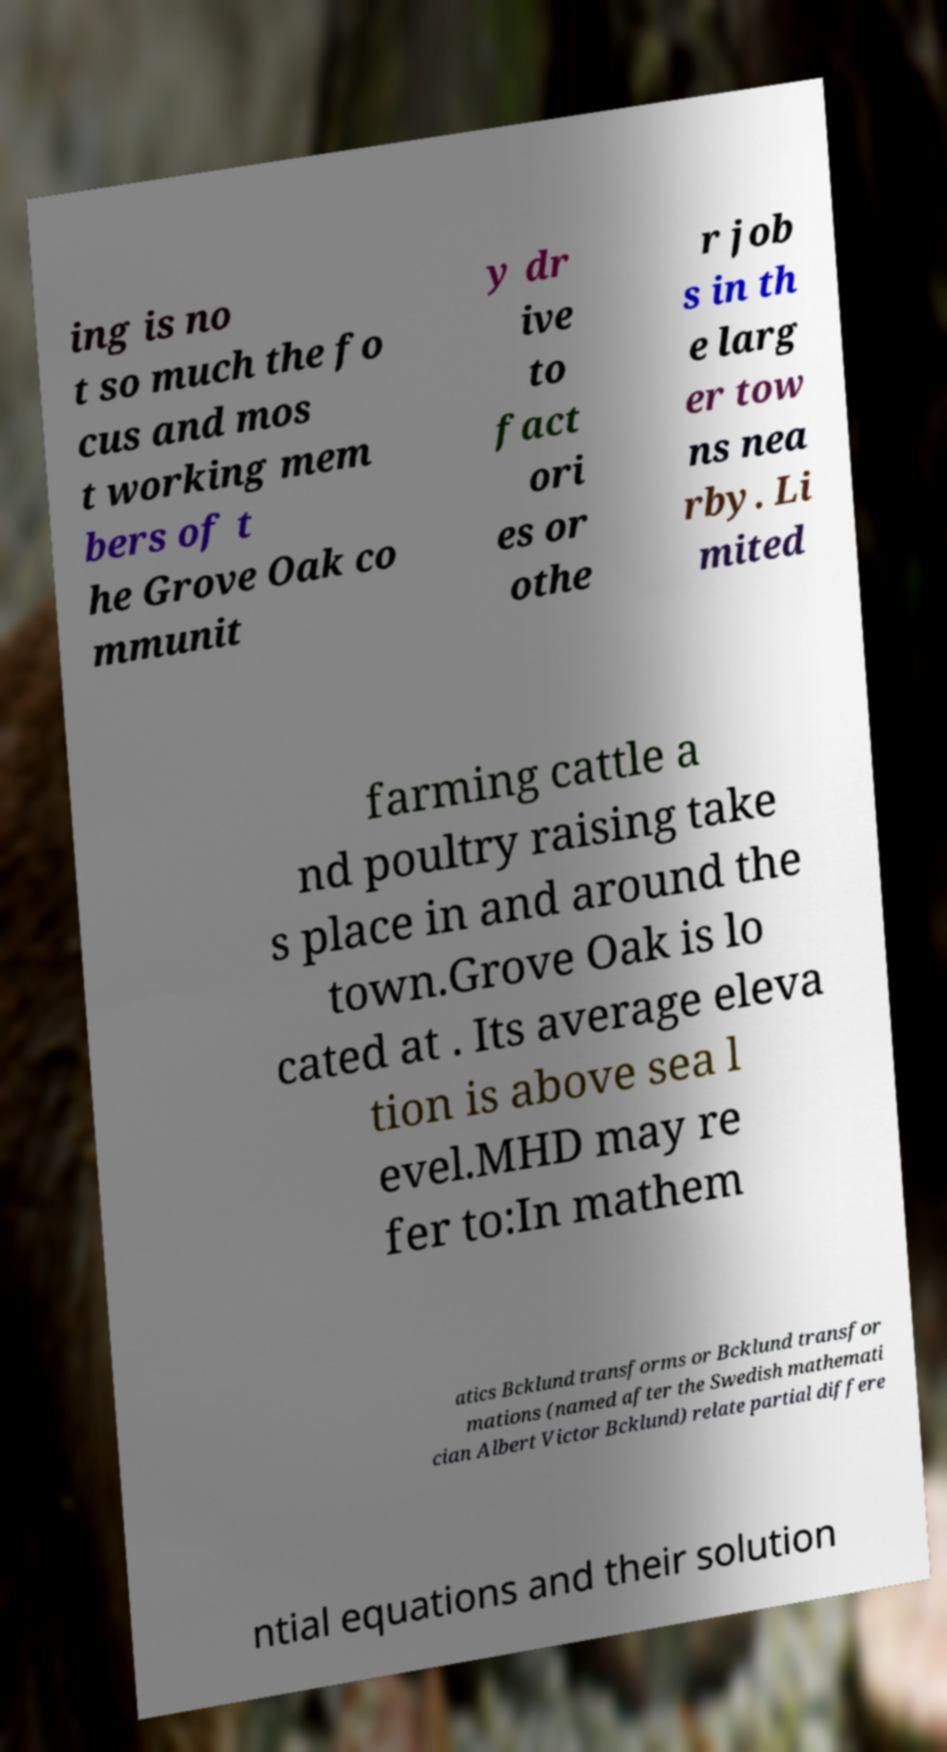There's text embedded in this image that I need extracted. Can you transcribe it verbatim? ing is no t so much the fo cus and mos t working mem bers of t he Grove Oak co mmunit y dr ive to fact ori es or othe r job s in th e larg er tow ns nea rby. Li mited farming cattle a nd poultry raising take s place in and around the town.Grove Oak is lo cated at . Its average eleva tion is above sea l evel.MHD may re fer to:In mathem atics Bcklund transforms or Bcklund transfor mations (named after the Swedish mathemati cian Albert Victor Bcklund) relate partial differe ntial equations and their solution 